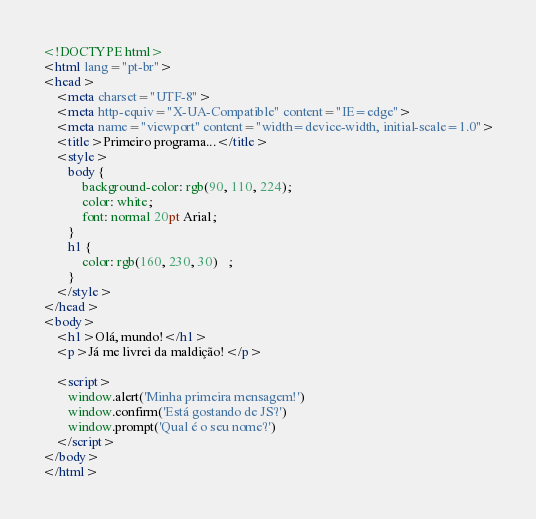Convert code to text. <code><loc_0><loc_0><loc_500><loc_500><_HTML_><!DOCTYPE html>
<html lang="pt-br">
<head>
    <meta charset="UTF-8">
    <meta http-equiv="X-UA-Compatible" content="IE=edge">
    <meta name="viewport" content="width=device-width, initial-scale=1.0">
    <title>Primeiro programa...</title>
    <style>
        body {
            background-color: rgb(90, 110, 224);
            color: white;
            font: normal 20pt Arial;
        }
        h1 {
            color: rgb(160, 230, 30)   ;
        }
    </style>
</head>
<body>
    <h1>Olá, mundo!</h1>
    <p>Já me livrei da maldição!</p>
    
    <script>
        window.alert('Minha primeira mensagem!')
        window.confirm('Está gostando de JS?')
        window.prompt('Qual é o seu nome?')
    </script>
</body>
</html></code> 